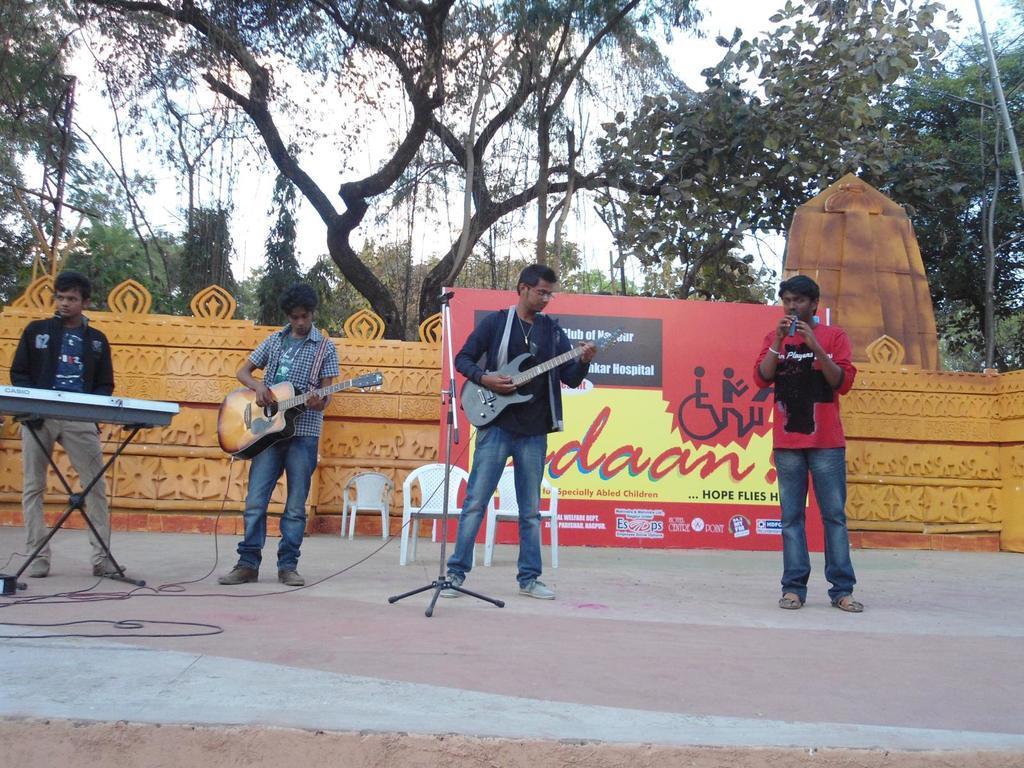Describe this image in one or two sentences. In this picture we can observe music band. There are four members standing on the floor. Two of them are playing guitar. One of them is playing keyboard. We can observe white color chairs. There is a red and yellow color poster in the background. We can observe orange color wall, trees and a sky. 